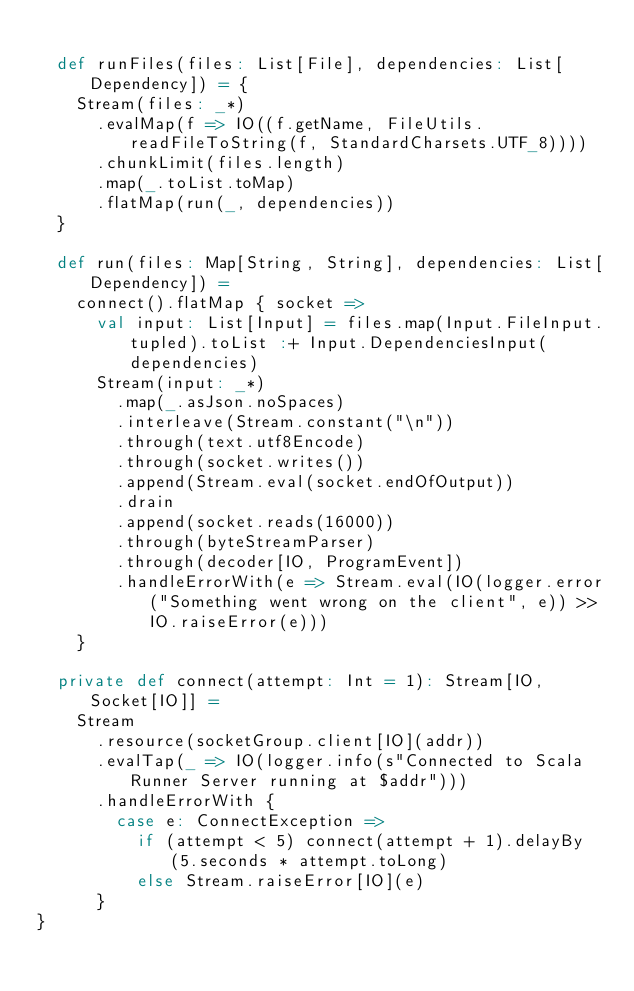Convert code to text. <code><loc_0><loc_0><loc_500><loc_500><_Scala_>
  def runFiles(files: List[File], dependencies: List[Dependency]) = {
    Stream(files: _*)
      .evalMap(f => IO((f.getName, FileUtils.readFileToString(f, StandardCharsets.UTF_8))))
      .chunkLimit(files.length)
      .map(_.toList.toMap)
      .flatMap(run(_, dependencies))
  }

  def run(files: Map[String, String], dependencies: List[Dependency]) =
    connect().flatMap { socket =>
      val input: List[Input] = files.map(Input.FileInput.tupled).toList :+ Input.DependenciesInput(dependencies)
      Stream(input: _*)
        .map(_.asJson.noSpaces)
        .interleave(Stream.constant("\n"))
        .through(text.utf8Encode)
        .through(socket.writes())
        .append(Stream.eval(socket.endOfOutput))
        .drain
        .append(socket.reads(16000))
        .through(byteStreamParser)
        .through(decoder[IO, ProgramEvent])
        .handleErrorWith(e => Stream.eval(IO(logger.error("Something went wrong on the client", e)) >> IO.raiseError(e)))
    }

  private def connect(attempt: Int = 1): Stream[IO, Socket[IO]] =
    Stream
      .resource(socketGroup.client[IO](addr))
      .evalTap(_ => IO(logger.info(s"Connected to Scala Runner Server running at $addr")))
      .handleErrorWith {
        case e: ConnectException =>
          if (attempt < 5) connect(attempt + 1).delayBy(5.seconds * attempt.toLong)
          else Stream.raiseError[IO](e)
      }
}
</code> 